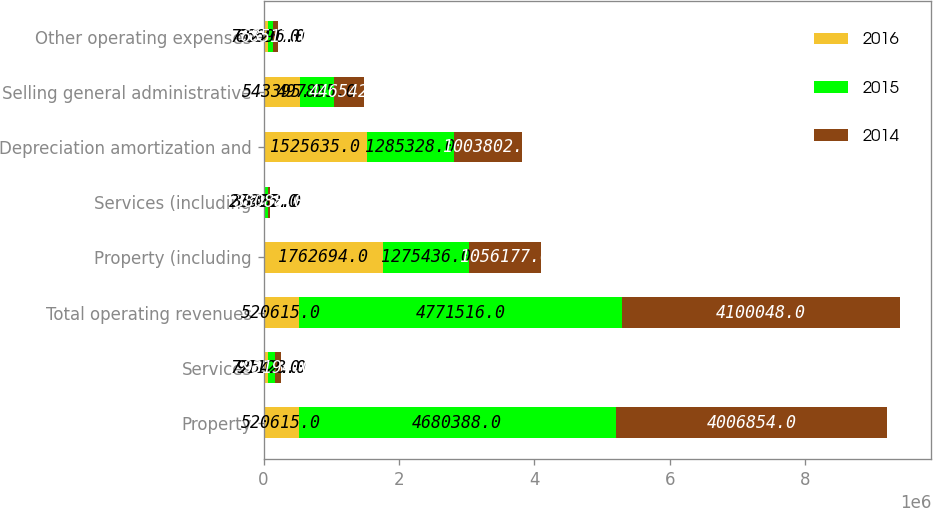<chart> <loc_0><loc_0><loc_500><loc_500><stacked_bar_chart><ecel><fcel>Property<fcel>Services<fcel>Total operating revenues<fcel>Property (including<fcel>Services (including<fcel>Depreciation amortization and<fcel>Selling general administrative<fcel>Other operating expenses<nl><fcel>2016<fcel>520615<fcel>72542<fcel>520615<fcel>1.76269e+06<fcel>27695<fcel>1.52564e+06<fcel>543395<fcel>73220<nl><fcel>2015<fcel>4.68039e+06<fcel>91128<fcel>4.77152e+06<fcel>1.27544e+06<fcel>33432<fcel>1.28533e+06<fcel>497835<fcel>66696<nl><fcel>2014<fcel>4.00685e+06<fcel>93194<fcel>4.10005e+06<fcel>1.05618e+06<fcel>38088<fcel>1.0038e+06<fcel>446542<fcel>68517<nl></chart> 